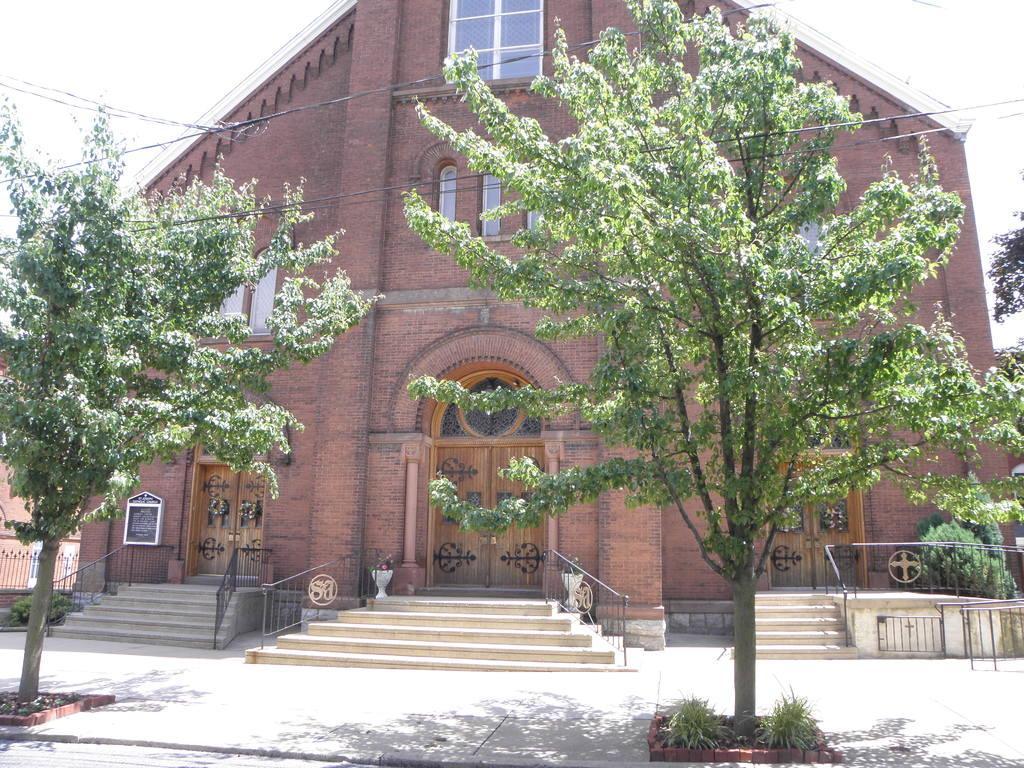Can you describe this image briefly? Here we can see trees,electric wires and plants. In the background there are buildings,windows,doors,steps,fences and a sky. 